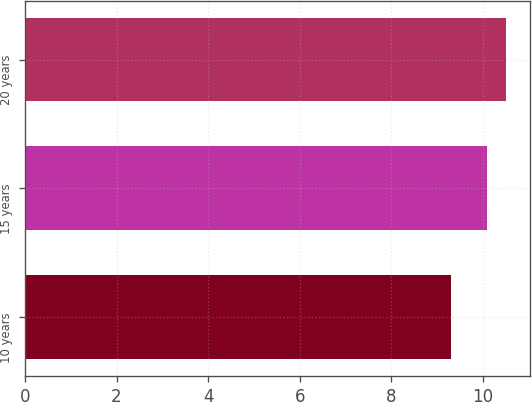Convert chart. <chart><loc_0><loc_0><loc_500><loc_500><bar_chart><fcel>10 years<fcel>15 years<fcel>20 years<nl><fcel>9.3<fcel>10.1<fcel>10.5<nl></chart> 